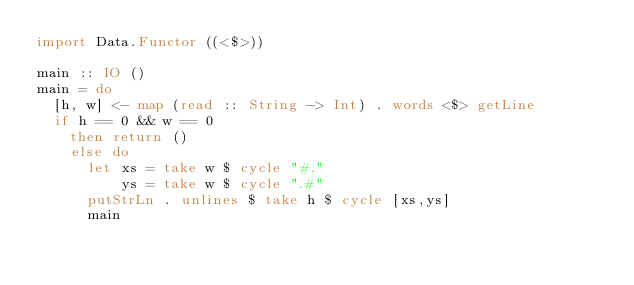<code> <loc_0><loc_0><loc_500><loc_500><_Haskell_>import Data.Functor ((<$>))

main :: IO ()
main = do
  [h, w] <- map (read :: String -> Int) . words <$> getLine
  if h == 0 && w == 0
    then return ()
    else do
      let xs = take w $ cycle "#."
          ys = take w $ cycle ".#"
      putStrLn . unlines $ take h $ cycle [xs,ys]
      main

</code> 